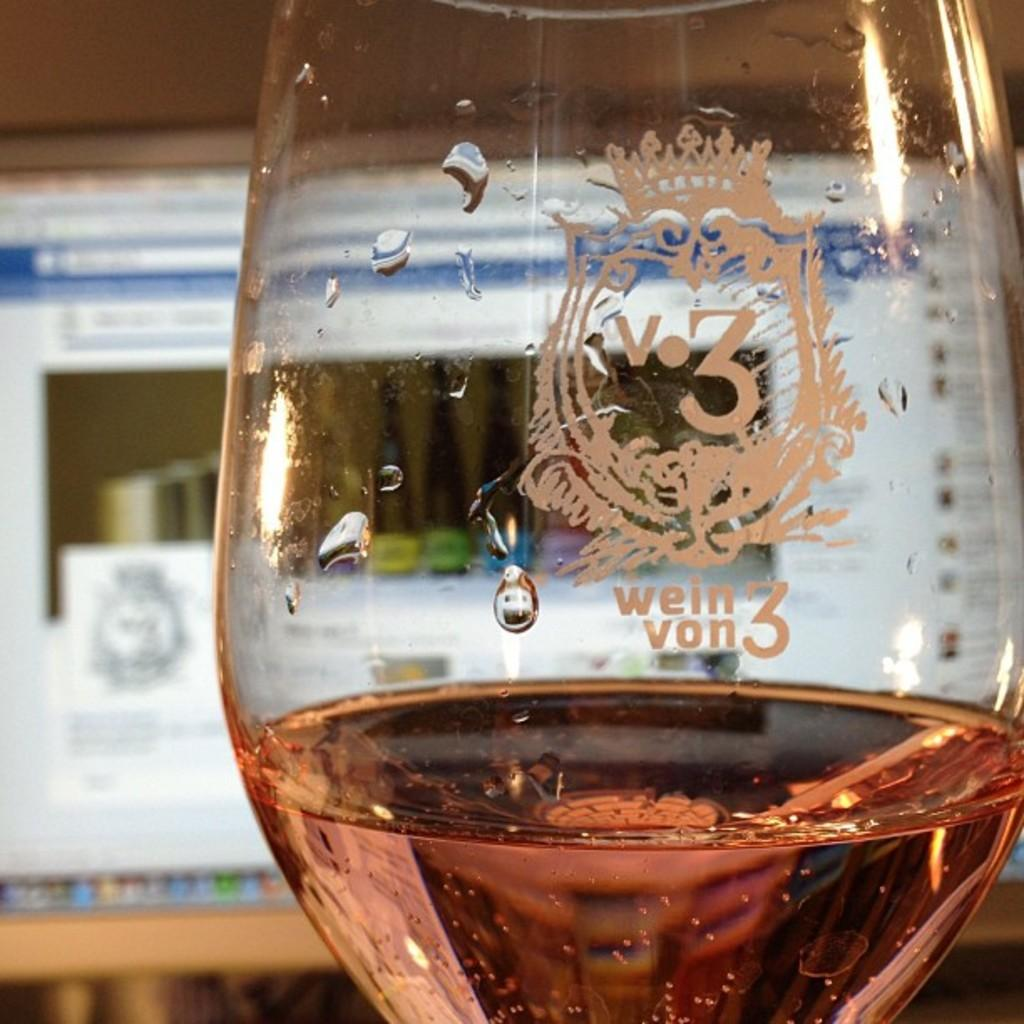What is inside the glass that is visible in the image? There is a glass containing liquid in the image. What electronic device is visible in the image? There is a monitor screen visible in the image. What type of structure can be seen in the image? There is a wall in the image. Can you see a key hanging on the wall in the image? There is no key visible on the wall in the image. Are there any snakes present in the image? There are no snakes present in the image. 